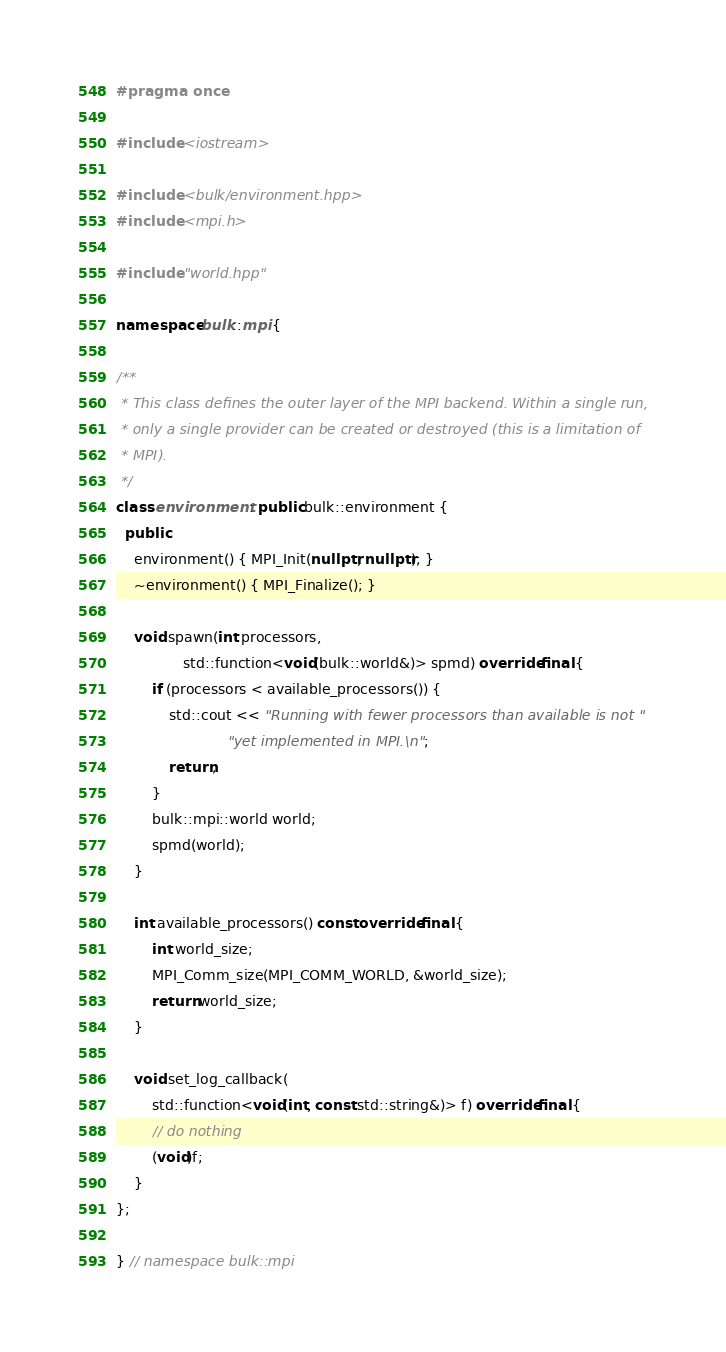Convert code to text. <code><loc_0><loc_0><loc_500><loc_500><_C++_>#pragma once

#include <iostream>

#include <bulk/environment.hpp>
#include <mpi.h>

#include "world.hpp"

namespace bulk::mpi {

/**
 * This class defines the outer layer of the MPI backend. Within a single run,
 * only a single provider can be created or destroyed (this is a limitation of
 * MPI).
 */
class environment : public bulk::environment {
  public:
    environment() { MPI_Init(nullptr, nullptr); }
    ~environment() { MPI_Finalize(); }

    void spawn(int processors,
               std::function<void(bulk::world&)> spmd) override final {
        if (processors < available_processors()) {
            std::cout << "Running with fewer processors than available is not "
                         "yet implemented in MPI.\n";
            return;
        }
        bulk::mpi::world world;
        spmd(world);
    }

    int available_processors() const override final {
        int world_size;
        MPI_Comm_size(MPI_COMM_WORLD, &world_size);
        return world_size;
    }

    void set_log_callback(
        std::function<void(int, const std::string&)> f) override final {
        // do nothing
        (void)f;
    }
};

} // namespace bulk::mpi
</code> 